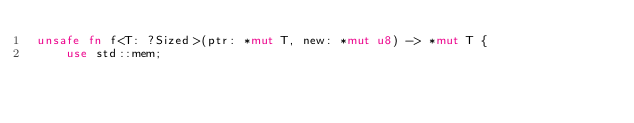<code> <loc_0><loc_0><loc_500><loc_500><_Rust_>unsafe fn f<T: ?Sized>(ptr: *mut T, new: *mut u8) -> *mut T {
    use std::mem;
</code> 